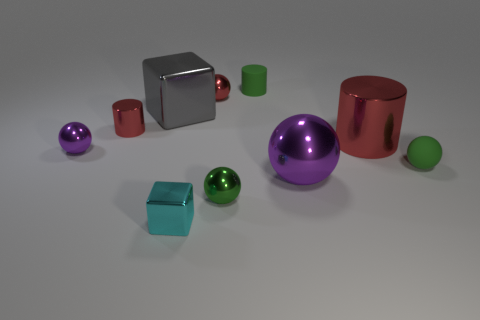The large metallic object that is left of the small green matte cylinder has what shape? The object to the left of the small green matte cylinder has a cube shape, with its six faces reflecting the environment and exhibiting a shiny, metallic texture. 